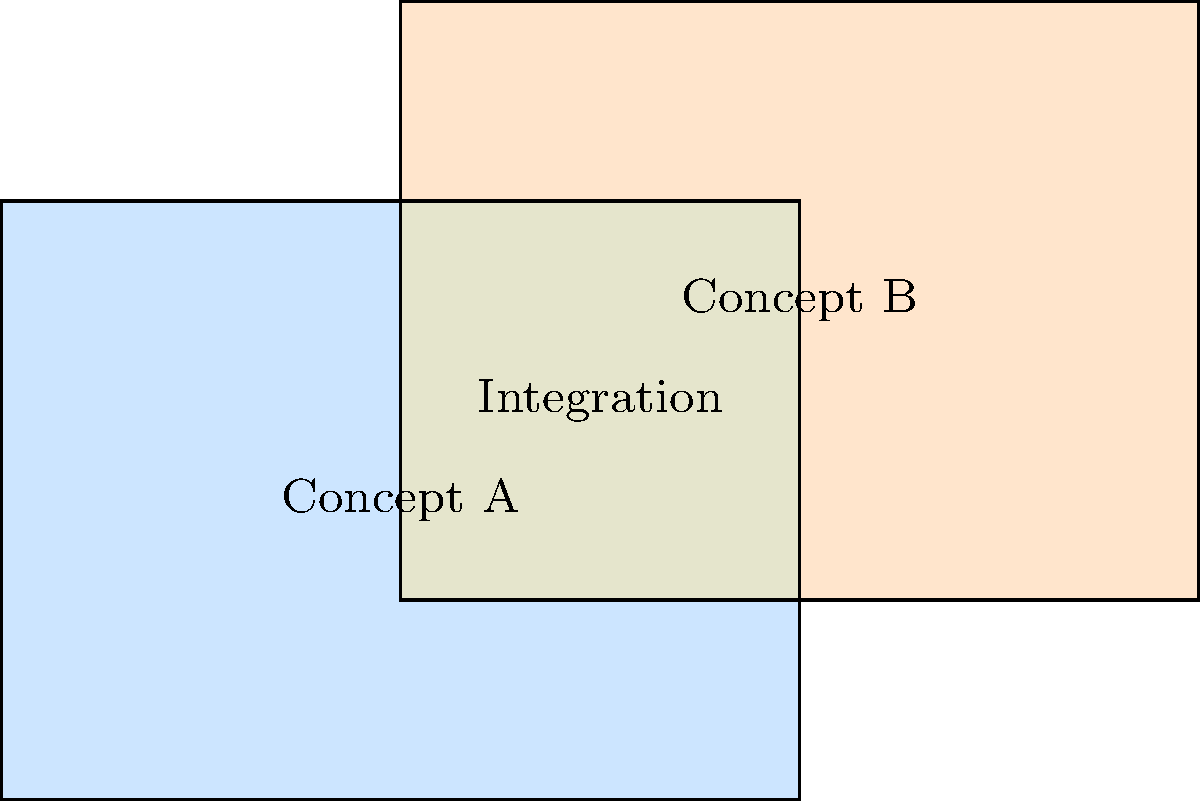In the context of integrating different learning concepts, consider the diagram where two rectangles represent distinct concepts (A and B) in a learning framework. Rectangle A has dimensions 4 units by 3 units, while Rectangle B measures 4 units by 3 units. They overlap as shown. If the area of overlap represents the integration of these concepts, what fraction of the total area covered by both rectangles does this integration represent? Express your answer as a simplified fraction. To solve this problem, let's follow these steps:

1) Calculate the area of Rectangle A:
   $A_A = 4 \times 3 = 12$ square units

2) Calculate the area of Rectangle B:
   $A_B = 4 \times 3 = 12$ square units

3) Calculate the area of overlap (integration):
   The overlap is 2 units wide and 2 units high.
   $A_{\text{overlap}} = 2 \times 2 = 4$ square units

4) Calculate the total area covered by both rectangles:
   $A_{\text{total}} = A_A + A_B - A_{\text{overlap}}$
   $A_{\text{total}} = 12 + 12 - 4 = 20$ square units

5) Calculate the fraction of integration:
   $\text{Fraction} = \frac{A_{\text{overlap}}}{A_{\text{total}}} = \frac{4}{20} = \frac{1}{5}$

Therefore, the integrated area represents $\frac{1}{5}$ of the total area covered by both concepts.
Answer: $\frac{1}{5}$ 